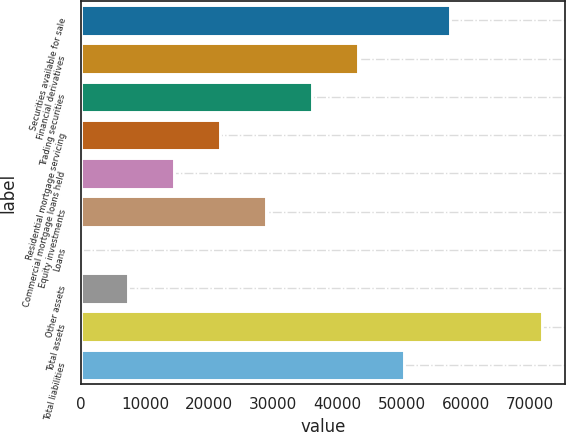Convert chart. <chart><loc_0><loc_0><loc_500><loc_500><bar_chart><fcel>Securities available for sale<fcel>Financial derivatives<fcel>Trading securities<fcel>Residential mortgage servicing<fcel>Commercial mortgage loans held<fcel>Equity investments<fcel>Loans<fcel>Other assets<fcel>Total assets<fcel>Total liabilities<nl><fcel>57543.2<fcel>43186.4<fcel>36008<fcel>21651.2<fcel>14472.8<fcel>28829.6<fcel>116<fcel>7294.4<fcel>71900<fcel>50364.8<nl></chart> 